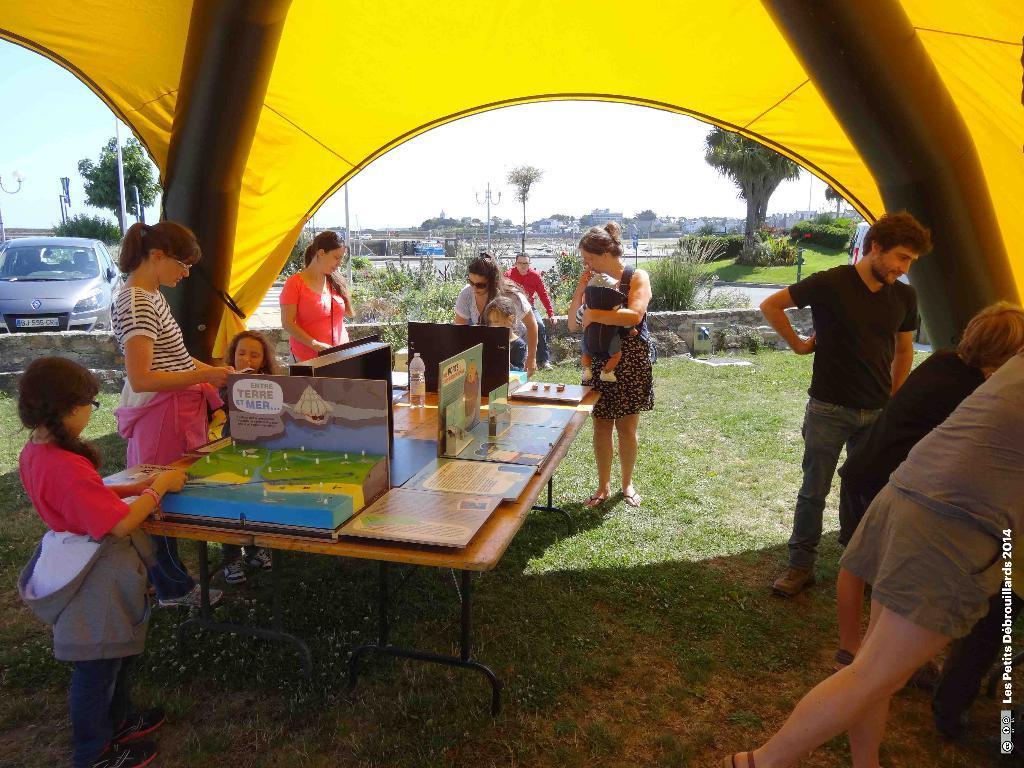In one or two sentences, can you explain what this image depicts? In the image there are some people under a tent. In the middle there is a table with cardboard,boxes,bottle. it seems to be of outdoor area. On left side there is a car parked. In front there are three,pole,road and above its sky. 